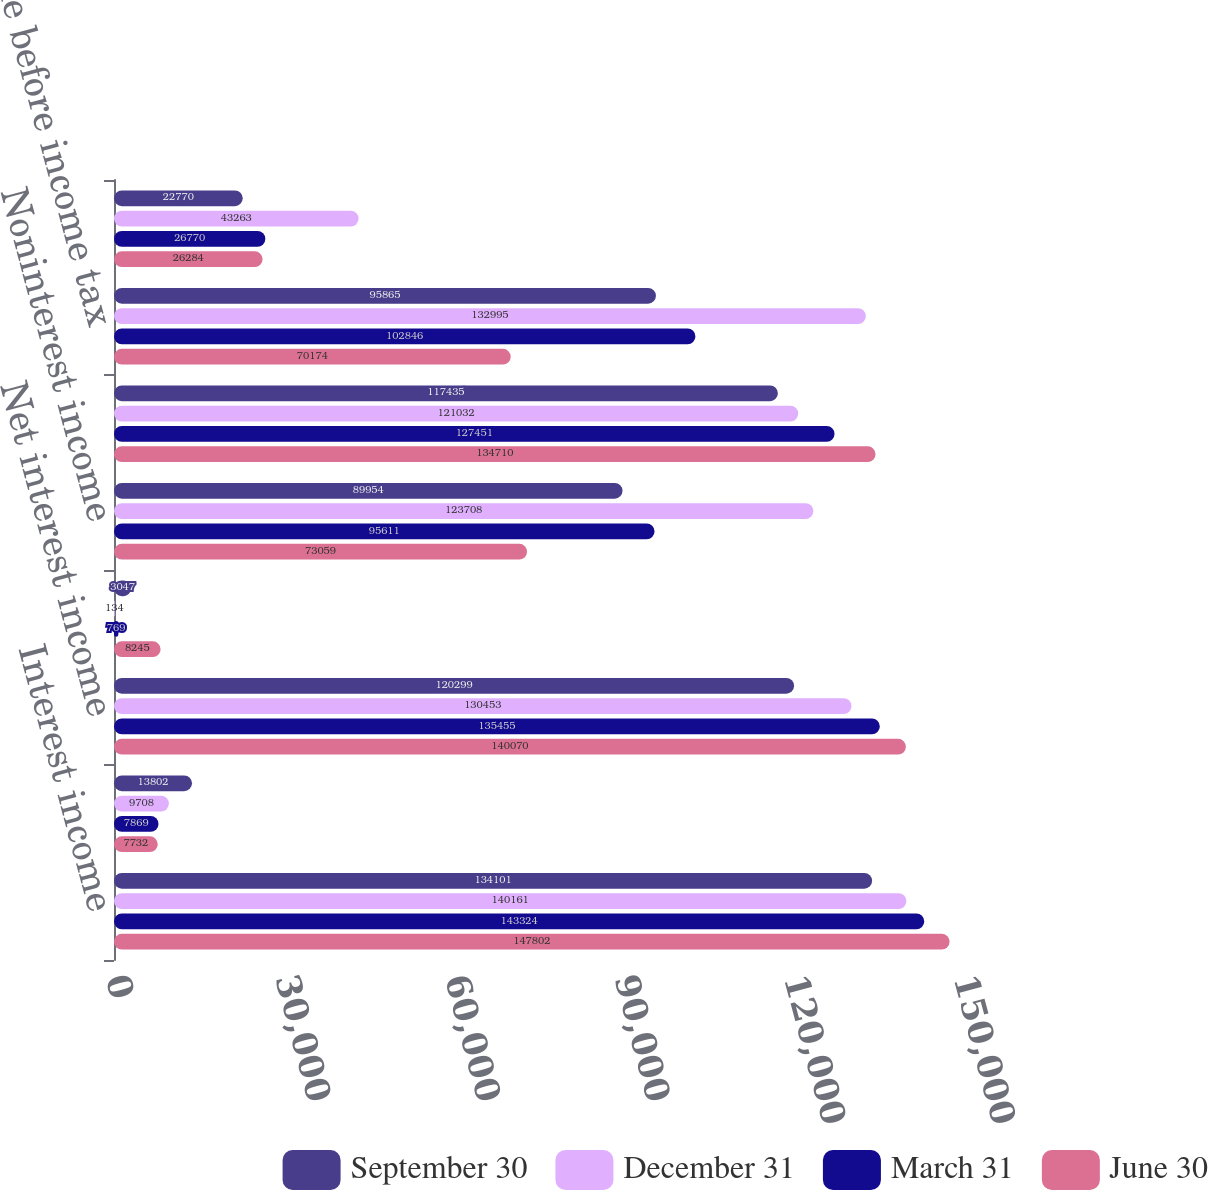Convert chart. <chart><loc_0><loc_0><loc_500><loc_500><stacked_bar_chart><ecel><fcel>Interest income<fcel>Interest expense<fcel>Net interest income<fcel>Reduction of (provision for)<fcel>Noninterest income<fcel>Noninterest expense<fcel>Income before income tax<fcel>Income tax expense<nl><fcel>September 30<fcel>134101<fcel>13802<fcel>120299<fcel>3047<fcel>89954<fcel>117435<fcel>95865<fcel>22770<nl><fcel>December 31<fcel>140161<fcel>9708<fcel>130453<fcel>134<fcel>123708<fcel>121032<fcel>132995<fcel>43263<nl><fcel>March 31<fcel>143324<fcel>7869<fcel>135455<fcel>769<fcel>95611<fcel>127451<fcel>102846<fcel>26770<nl><fcel>June 30<fcel>147802<fcel>7732<fcel>140070<fcel>8245<fcel>73059<fcel>134710<fcel>70174<fcel>26284<nl></chart> 